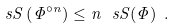Convert formula to latex. <formula><loc_0><loc_0><loc_500><loc_500>\ s S \left ( \Phi ^ { \circ n } \right ) \leq n \, \ s S ( \Phi ) \ .</formula> 